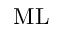<formula> <loc_0><loc_0><loc_500><loc_500>M L</formula> 